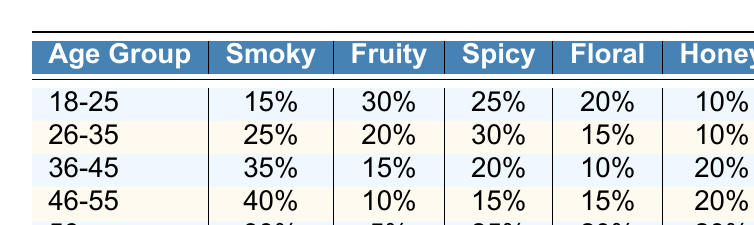What is the most preferred whisky flavor among the 18-25 age group? The table shows that the highest percentage for the 18-25 age group is for the Fruity flavor at 30%.
Answer: Fruity Which age group has the least preference for Floral whisky? The 36-45 age group has the least preference for Floral whisky, with only 10%.
Answer: 36-45 What is the total percentage preference for Smoky whisky across all age groups? Summing the percentages: 15 + 25 + 35 + 40 + 30 = 135%.
Answer: 135% Is the preference for Spicy whisky higher or lower than Honey whisky in the 46-55 age group? The preference for Spicy whisky is 15%, while for Honey whisky it is 20%. Since 15% is lower than 20%, the preference for Spicy is lower.
Answer: Lower Which age group shows a preference for Smoky whisky that is more than 30%? The age groups 36-45 (35%) and 46-55 (40%) both have preferences for Smoky whisky that are above 30%.
Answer: 36-45 and 46-55 In which age group is the difference between the preference for Fruity and Smoky whisky the largest? In the 46-55 age group, Smoky whisky is preferred at 40%, while Fruity whisky is preferred at 10%. The difference is 40% - 10% = 30%.
Answer: 46-55 What percentage of the 56+ age group prefers Floral whisky? The table indicates that the 56+ age group has a preference of 20% for Floral whisky.
Answer: 20% What is the average preference for Honey whisky across all age groups? Calculate the average by adding the percentages (10 + 10 + 20 + 20 + 20) and dividing by the number of age groups (5): (10 + 10 + 20 + 20 + 20) / 5 = 18%.
Answer: 18% Do any of the age groups have a preference of 5% or less for any whisky flavor? Yes, the 56+ age group has a preference of 5% for Fruity whisky.
Answer: Yes Which age group's preference for Spicy whisky is exactly equal to the preference for Honey whisky? The 26-35 age group has a preference of 30% for Spicy and 10% for Honey, so no group has equal preference for both.
Answer: None 